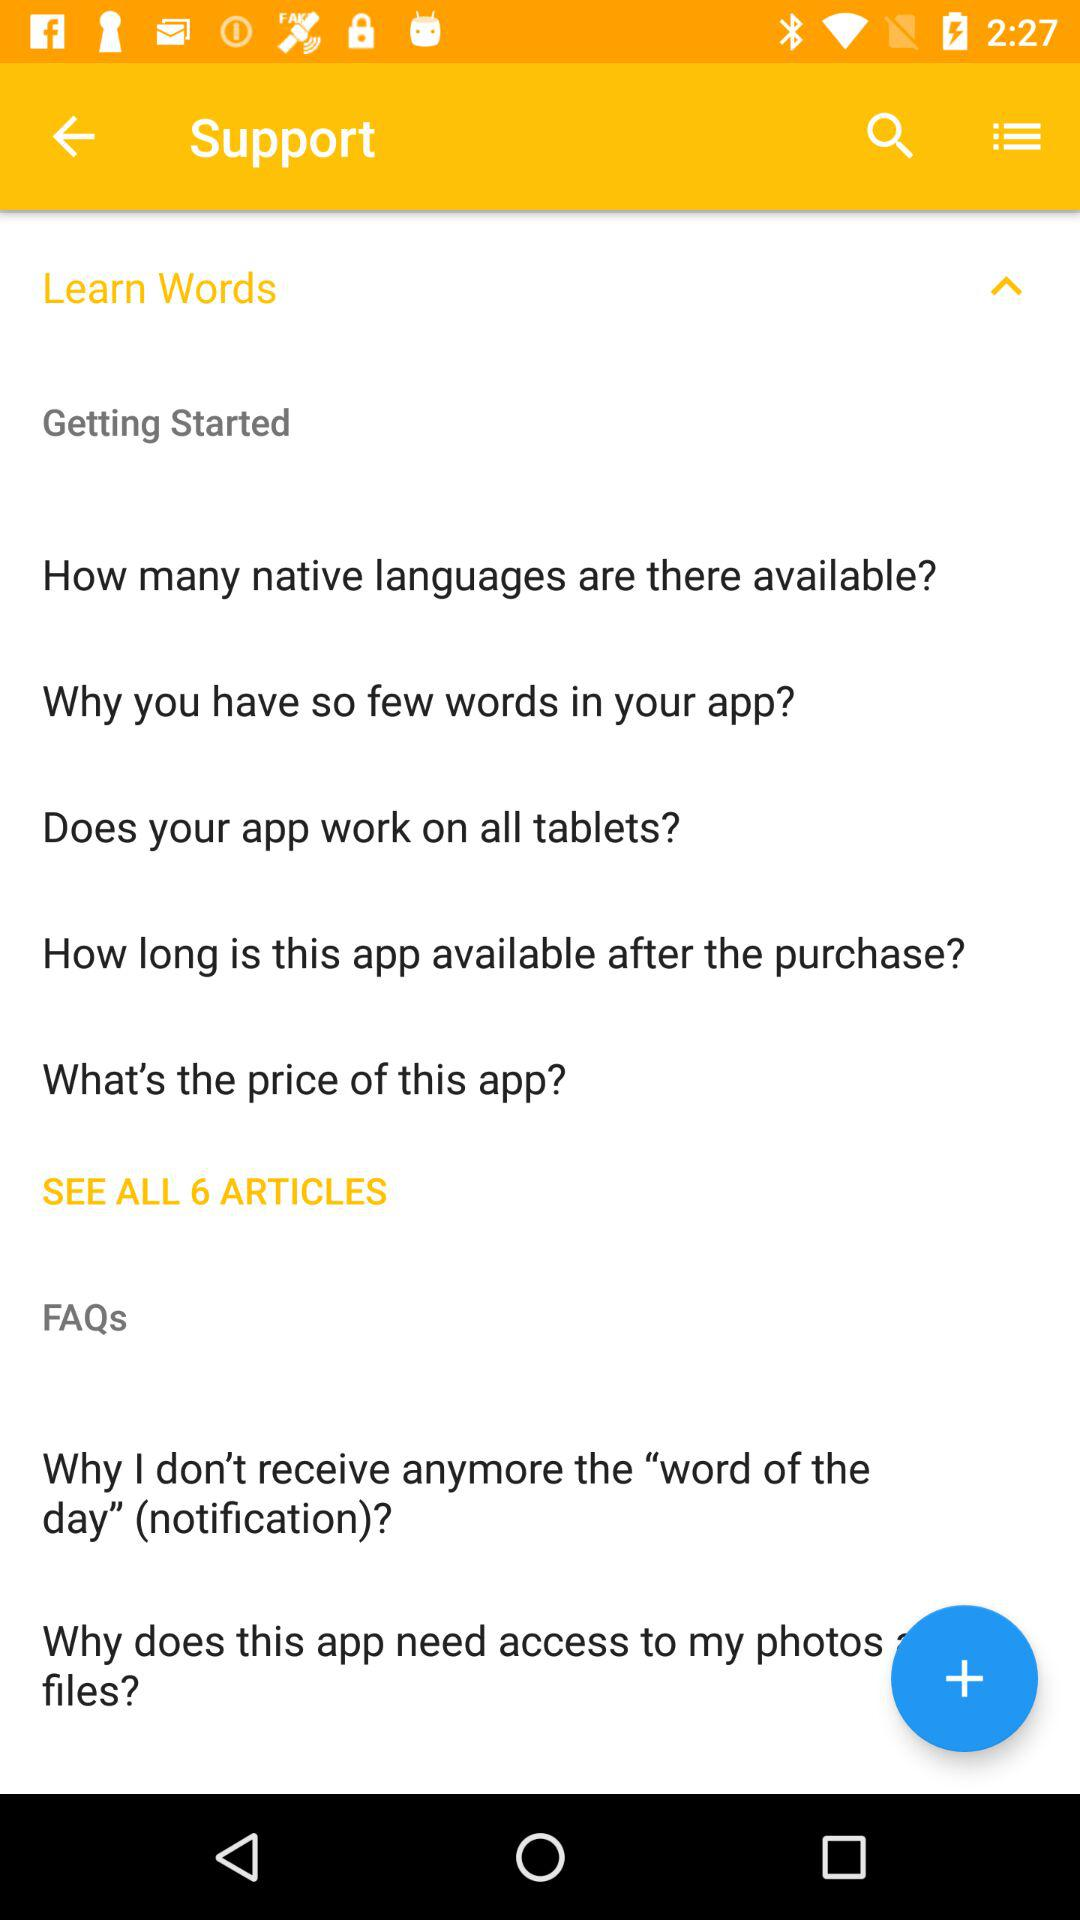How many articles are there in the FAQ section?
Answer the question using a single word or phrase. 6 